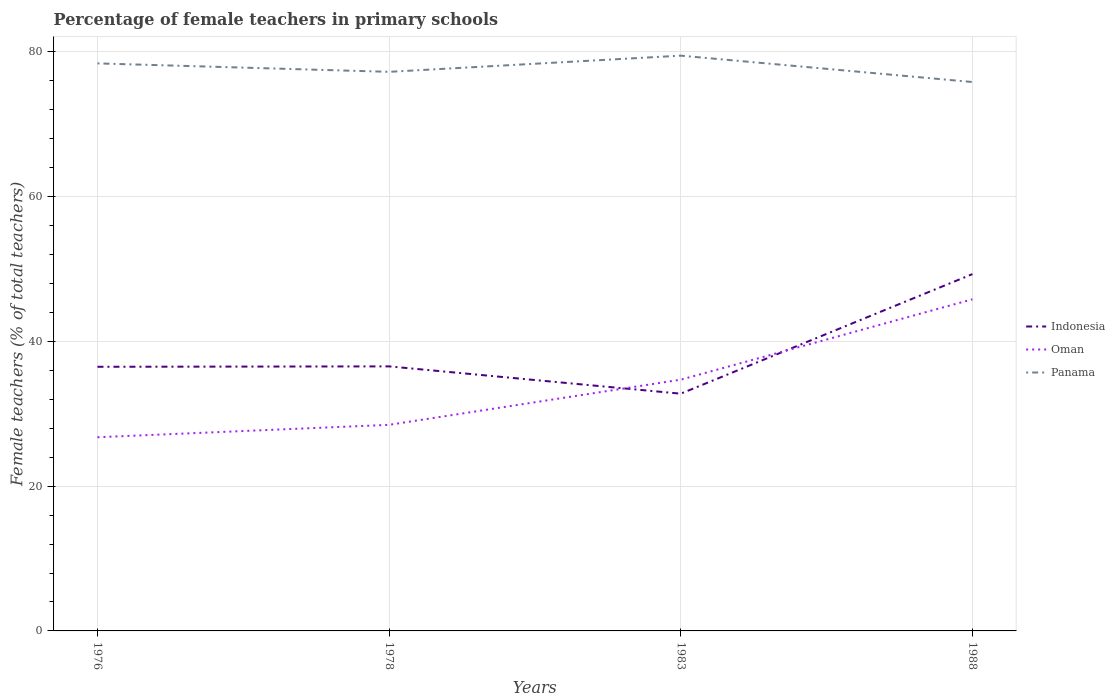Does the line corresponding to Panama intersect with the line corresponding to Oman?
Make the answer very short. No. Is the number of lines equal to the number of legend labels?
Make the answer very short. Yes. Across all years, what is the maximum percentage of female teachers in Oman?
Provide a succinct answer. 26.76. What is the total percentage of female teachers in Panama in the graph?
Offer a very short reply. -2.24. What is the difference between the highest and the second highest percentage of female teachers in Panama?
Keep it short and to the point. 3.64. Is the percentage of female teachers in Panama strictly greater than the percentage of female teachers in Oman over the years?
Your response must be concise. No. How many years are there in the graph?
Offer a terse response. 4. What is the difference between two consecutive major ticks on the Y-axis?
Give a very brief answer. 20. Are the values on the major ticks of Y-axis written in scientific E-notation?
Your response must be concise. No. Where does the legend appear in the graph?
Your answer should be very brief. Center right. How many legend labels are there?
Your answer should be very brief. 3. What is the title of the graph?
Keep it short and to the point. Percentage of female teachers in primary schools. What is the label or title of the X-axis?
Offer a very short reply. Years. What is the label or title of the Y-axis?
Your response must be concise. Female teachers (% of total teachers). What is the Female teachers (% of total teachers) of Indonesia in 1976?
Offer a very short reply. 36.5. What is the Female teachers (% of total teachers) of Oman in 1976?
Provide a short and direct response. 26.76. What is the Female teachers (% of total teachers) in Panama in 1976?
Your answer should be compact. 78.42. What is the Female teachers (% of total teachers) in Indonesia in 1978?
Your response must be concise. 36.55. What is the Female teachers (% of total teachers) in Oman in 1978?
Offer a terse response. 28.48. What is the Female teachers (% of total teachers) in Panama in 1978?
Your answer should be very brief. 77.26. What is the Female teachers (% of total teachers) in Indonesia in 1983?
Offer a very short reply. 32.78. What is the Female teachers (% of total teachers) in Oman in 1983?
Your response must be concise. 34.72. What is the Female teachers (% of total teachers) of Panama in 1983?
Offer a very short reply. 79.49. What is the Female teachers (% of total teachers) of Indonesia in 1988?
Keep it short and to the point. 49.31. What is the Female teachers (% of total teachers) of Oman in 1988?
Your answer should be very brief. 45.82. What is the Female teachers (% of total teachers) in Panama in 1988?
Provide a succinct answer. 75.85. Across all years, what is the maximum Female teachers (% of total teachers) of Indonesia?
Make the answer very short. 49.31. Across all years, what is the maximum Female teachers (% of total teachers) in Oman?
Offer a terse response. 45.82. Across all years, what is the maximum Female teachers (% of total teachers) of Panama?
Your response must be concise. 79.49. Across all years, what is the minimum Female teachers (% of total teachers) in Indonesia?
Offer a very short reply. 32.78. Across all years, what is the minimum Female teachers (% of total teachers) of Oman?
Keep it short and to the point. 26.76. Across all years, what is the minimum Female teachers (% of total teachers) in Panama?
Your answer should be compact. 75.85. What is the total Female teachers (% of total teachers) of Indonesia in the graph?
Keep it short and to the point. 155.14. What is the total Female teachers (% of total teachers) in Oman in the graph?
Make the answer very short. 135.78. What is the total Female teachers (% of total teachers) in Panama in the graph?
Your answer should be compact. 311.02. What is the difference between the Female teachers (% of total teachers) of Indonesia in 1976 and that in 1978?
Provide a short and direct response. -0.06. What is the difference between the Female teachers (% of total teachers) in Oman in 1976 and that in 1978?
Make the answer very short. -1.71. What is the difference between the Female teachers (% of total teachers) in Panama in 1976 and that in 1978?
Your response must be concise. 1.17. What is the difference between the Female teachers (% of total teachers) in Indonesia in 1976 and that in 1983?
Provide a succinct answer. 3.72. What is the difference between the Female teachers (% of total teachers) of Oman in 1976 and that in 1983?
Keep it short and to the point. -7.95. What is the difference between the Female teachers (% of total teachers) in Panama in 1976 and that in 1983?
Your response must be concise. -1.07. What is the difference between the Female teachers (% of total teachers) of Indonesia in 1976 and that in 1988?
Offer a terse response. -12.81. What is the difference between the Female teachers (% of total teachers) in Oman in 1976 and that in 1988?
Make the answer very short. -19.06. What is the difference between the Female teachers (% of total teachers) of Panama in 1976 and that in 1988?
Your answer should be very brief. 2.57. What is the difference between the Female teachers (% of total teachers) in Indonesia in 1978 and that in 1983?
Your answer should be compact. 3.77. What is the difference between the Female teachers (% of total teachers) of Oman in 1978 and that in 1983?
Give a very brief answer. -6.24. What is the difference between the Female teachers (% of total teachers) in Panama in 1978 and that in 1983?
Ensure brevity in your answer.  -2.24. What is the difference between the Female teachers (% of total teachers) of Indonesia in 1978 and that in 1988?
Your answer should be very brief. -12.75. What is the difference between the Female teachers (% of total teachers) in Oman in 1978 and that in 1988?
Keep it short and to the point. -17.34. What is the difference between the Female teachers (% of total teachers) in Panama in 1978 and that in 1988?
Provide a succinct answer. 1.41. What is the difference between the Female teachers (% of total teachers) of Indonesia in 1983 and that in 1988?
Provide a succinct answer. -16.52. What is the difference between the Female teachers (% of total teachers) of Oman in 1983 and that in 1988?
Your response must be concise. -11.11. What is the difference between the Female teachers (% of total teachers) of Panama in 1983 and that in 1988?
Provide a short and direct response. 3.64. What is the difference between the Female teachers (% of total teachers) of Indonesia in 1976 and the Female teachers (% of total teachers) of Oman in 1978?
Your answer should be very brief. 8.02. What is the difference between the Female teachers (% of total teachers) of Indonesia in 1976 and the Female teachers (% of total teachers) of Panama in 1978?
Provide a succinct answer. -40.76. What is the difference between the Female teachers (% of total teachers) in Oman in 1976 and the Female teachers (% of total teachers) in Panama in 1978?
Your response must be concise. -50.49. What is the difference between the Female teachers (% of total teachers) of Indonesia in 1976 and the Female teachers (% of total teachers) of Oman in 1983?
Your response must be concise. 1.78. What is the difference between the Female teachers (% of total teachers) of Indonesia in 1976 and the Female teachers (% of total teachers) of Panama in 1983?
Provide a short and direct response. -42.99. What is the difference between the Female teachers (% of total teachers) of Oman in 1976 and the Female teachers (% of total teachers) of Panama in 1983?
Give a very brief answer. -52.73. What is the difference between the Female teachers (% of total teachers) of Indonesia in 1976 and the Female teachers (% of total teachers) of Oman in 1988?
Ensure brevity in your answer.  -9.32. What is the difference between the Female teachers (% of total teachers) of Indonesia in 1976 and the Female teachers (% of total teachers) of Panama in 1988?
Offer a very short reply. -39.35. What is the difference between the Female teachers (% of total teachers) of Oman in 1976 and the Female teachers (% of total teachers) of Panama in 1988?
Make the answer very short. -49.08. What is the difference between the Female teachers (% of total teachers) in Indonesia in 1978 and the Female teachers (% of total teachers) in Oman in 1983?
Your answer should be compact. 1.84. What is the difference between the Female teachers (% of total teachers) of Indonesia in 1978 and the Female teachers (% of total teachers) of Panama in 1983?
Ensure brevity in your answer.  -42.94. What is the difference between the Female teachers (% of total teachers) of Oman in 1978 and the Female teachers (% of total teachers) of Panama in 1983?
Provide a succinct answer. -51.01. What is the difference between the Female teachers (% of total teachers) in Indonesia in 1978 and the Female teachers (% of total teachers) in Oman in 1988?
Offer a terse response. -9.27. What is the difference between the Female teachers (% of total teachers) of Indonesia in 1978 and the Female teachers (% of total teachers) of Panama in 1988?
Offer a very short reply. -39.29. What is the difference between the Female teachers (% of total teachers) of Oman in 1978 and the Female teachers (% of total teachers) of Panama in 1988?
Give a very brief answer. -47.37. What is the difference between the Female teachers (% of total teachers) of Indonesia in 1983 and the Female teachers (% of total teachers) of Oman in 1988?
Offer a very short reply. -13.04. What is the difference between the Female teachers (% of total teachers) in Indonesia in 1983 and the Female teachers (% of total teachers) in Panama in 1988?
Offer a very short reply. -43.07. What is the difference between the Female teachers (% of total teachers) of Oman in 1983 and the Female teachers (% of total teachers) of Panama in 1988?
Make the answer very short. -41.13. What is the average Female teachers (% of total teachers) of Indonesia per year?
Give a very brief answer. 38.79. What is the average Female teachers (% of total teachers) in Oman per year?
Your response must be concise. 33.95. What is the average Female teachers (% of total teachers) in Panama per year?
Your answer should be compact. 77.75. In the year 1976, what is the difference between the Female teachers (% of total teachers) in Indonesia and Female teachers (% of total teachers) in Oman?
Give a very brief answer. 9.73. In the year 1976, what is the difference between the Female teachers (% of total teachers) in Indonesia and Female teachers (% of total teachers) in Panama?
Your answer should be very brief. -41.92. In the year 1976, what is the difference between the Female teachers (% of total teachers) in Oman and Female teachers (% of total teachers) in Panama?
Provide a short and direct response. -51.66. In the year 1978, what is the difference between the Female teachers (% of total teachers) in Indonesia and Female teachers (% of total teachers) in Oman?
Provide a short and direct response. 8.08. In the year 1978, what is the difference between the Female teachers (% of total teachers) in Indonesia and Female teachers (% of total teachers) in Panama?
Your answer should be compact. -40.7. In the year 1978, what is the difference between the Female teachers (% of total teachers) in Oman and Female teachers (% of total teachers) in Panama?
Provide a succinct answer. -48.78. In the year 1983, what is the difference between the Female teachers (% of total teachers) in Indonesia and Female teachers (% of total teachers) in Oman?
Ensure brevity in your answer.  -1.93. In the year 1983, what is the difference between the Female teachers (% of total teachers) in Indonesia and Female teachers (% of total teachers) in Panama?
Offer a very short reply. -46.71. In the year 1983, what is the difference between the Female teachers (% of total teachers) in Oman and Female teachers (% of total teachers) in Panama?
Keep it short and to the point. -44.77. In the year 1988, what is the difference between the Female teachers (% of total teachers) in Indonesia and Female teachers (% of total teachers) in Oman?
Provide a succinct answer. 3.48. In the year 1988, what is the difference between the Female teachers (% of total teachers) in Indonesia and Female teachers (% of total teachers) in Panama?
Your response must be concise. -26.54. In the year 1988, what is the difference between the Female teachers (% of total teachers) of Oman and Female teachers (% of total teachers) of Panama?
Provide a short and direct response. -30.03. What is the ratio of the Female teachers (% of total teachers) of Indonesia in 1976 to that in 1978?
Provide a succinct answer. 1. What is the ratio of the Female teachers (% of total teachers) of Oman in 1976 to that in 1978?
Offer a terse response. 0.94. What is the ratio of the Female teachers (% of total teachers) in Panama in 1976 to that in 1978?
Offer a very short reply. 1.02. What is the ratio of the Female teachers (% of total teachers) of Indonesia in 1976 to that in 1983?
Ensure brevity in your answer.  1.11. What is the ratio of the Female teachers (% of total teachers) in Oman in 1976 to that in 1983?
Keep it short and to the point. 0.77. What is the ratio of the Female teachers (% of total teachers) in Panama in 1976 to that in 1983?
Ensure brevity in your answer.  0.99. What is the ratio of the Female teachers (% of total teachers) of Indonesia in 1976 to that in 1988?
Ensure brevity in your answer.  0.74. What is the ratio of the Female teachers (% of total teachers) in Oman in 1976 to that in 1988?
Ensure brevity in your answer.  0.58. What is the ratio of the Female teachers (% of total teachers) in Panama in 1976 to that in 1988?
Offer a terse response. 1.03. What is the ratio of the Female teachers (% of total teachers) of Indonesia in 1978 to that in 1983?
Ensure brevity in your answer.  1.12. What is the ratio of the Female teachers (% of total teachers) of Oman in 1978 to that in 1983?
Provide a succinct answer. 0.82. What is the ratio of the Female teachers (% of total teachers) in Panama in 1978 to that in 1983?
Your answer should be very brief. 0.97. What is the ratio of the Female teachers (% of total teachers) of Indonesia in 1978 to that in 1988?
Ensure brevity in your answer.  0.74. What is the ratio of the Female teachers (% of total teachers) in Oman in 1978 to that in 1988?
Provide a succinct answer. 0.62. What is the ratio of the Female teachers (% of total teachers) in Panama in 1978 to that in 1988?
Give a very brief answer. 1.02. What is the ratio of the Female teachers (% of total teachers) in Indonesia in 1983 to that in 1988?
Your response must be concise. 0.66. What is the ratio of the Female teachers (% of total teachers) in Oman in 1983 to that in 1988?
Offer a very short reply. 0.76. What is the ratio of the Female teachers (% of total teachers) in Panama in 1983 to that in 1988?
Your response must be concise. 1.05. What is the difference between the highest and the second highest Female teachers (% of total teachers) in Indonesia?
Offer a very short reply. 12.75. What is the difference between the highest and the second highest Female teachers (% of total teachers) of Oman?
Ensure brevity in your answer.  11.11. What is the difference between the highest and the second highest Female teachers (% of total teachers) of Panama?
Provide a succinct answer. 1.07. What is the difference between the highest and the lowest Female teachers (% of total teachers) in Indonesia?
Your answer should be compact. 16.52. What is the difference between the highest and the lowest Female teachers (% of total teachers) in Oman?
Ensure brevity in your answer.  19.06. What is the difference between the highest and the lowest Female teachers (% of total teachers) in Panama?
Provide a short and direct response. 3.64. 